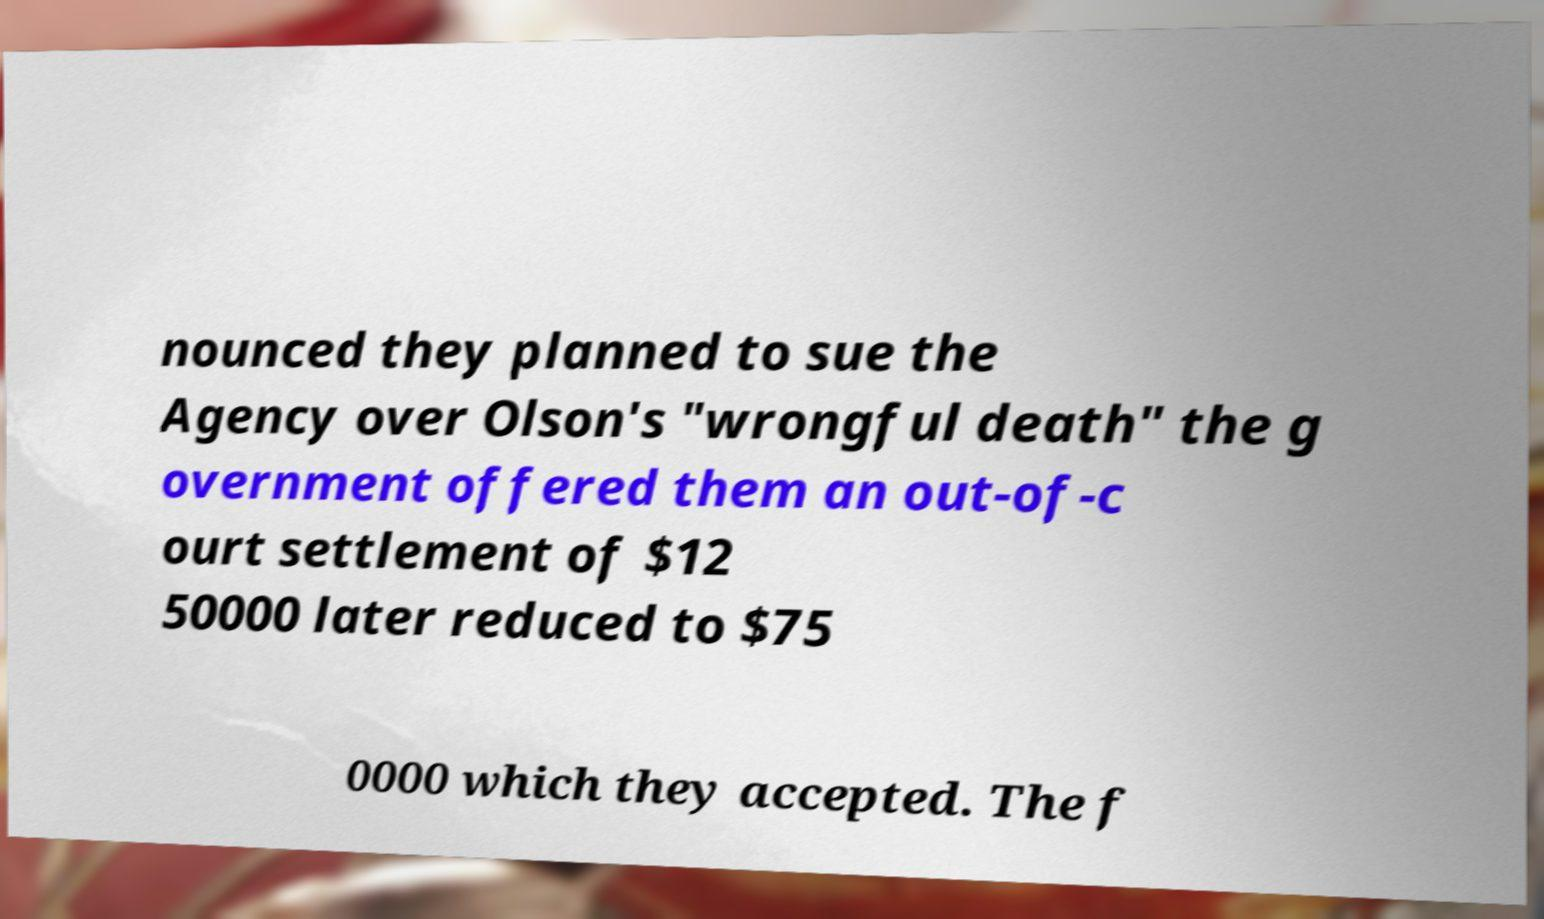Can you accurately transcribe the text from the provided image for me? nounced they planned to sue the Agency over Olson's "wrongful death" the g overnment offered them an out-of-c ourt settlement of $12 50000 later reduced to $75 0000 which they accepted. The f 